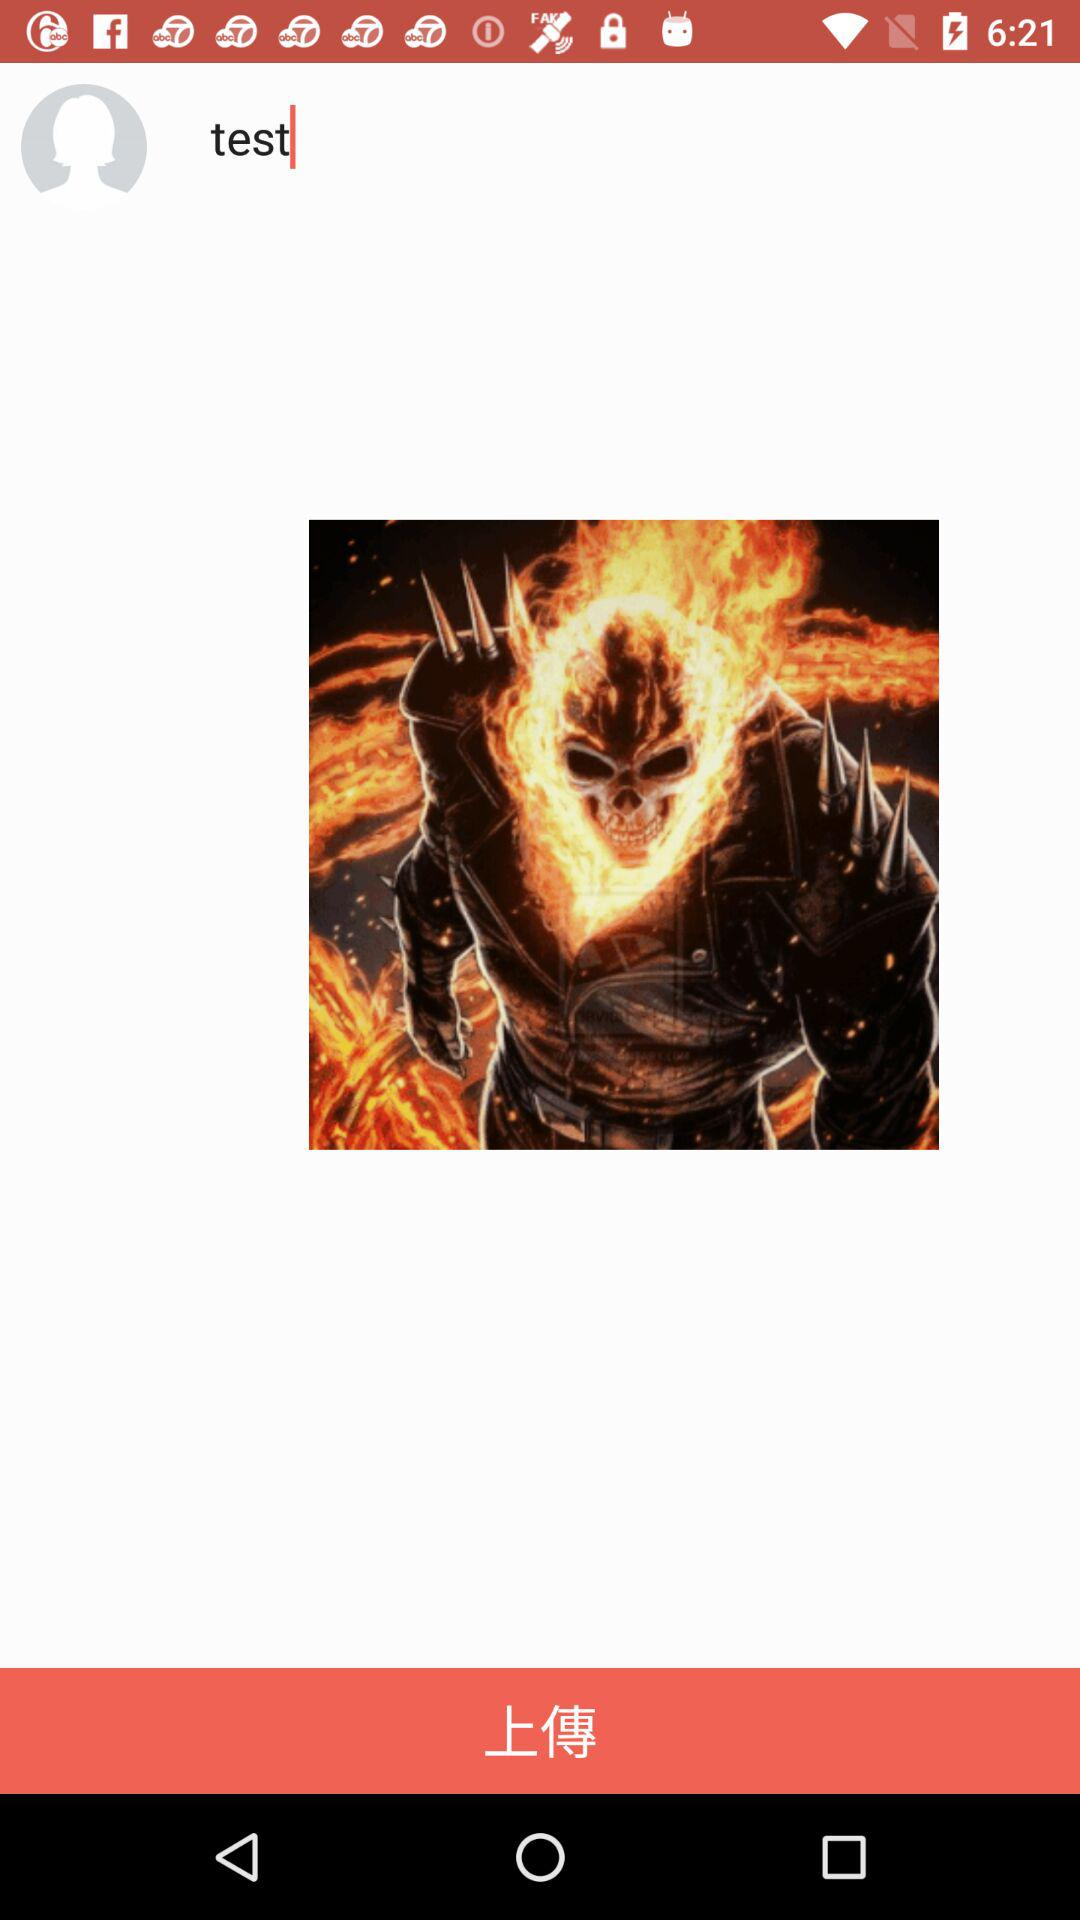What is the text that is entered into the text input? The text that is entered into the text input is "test". 